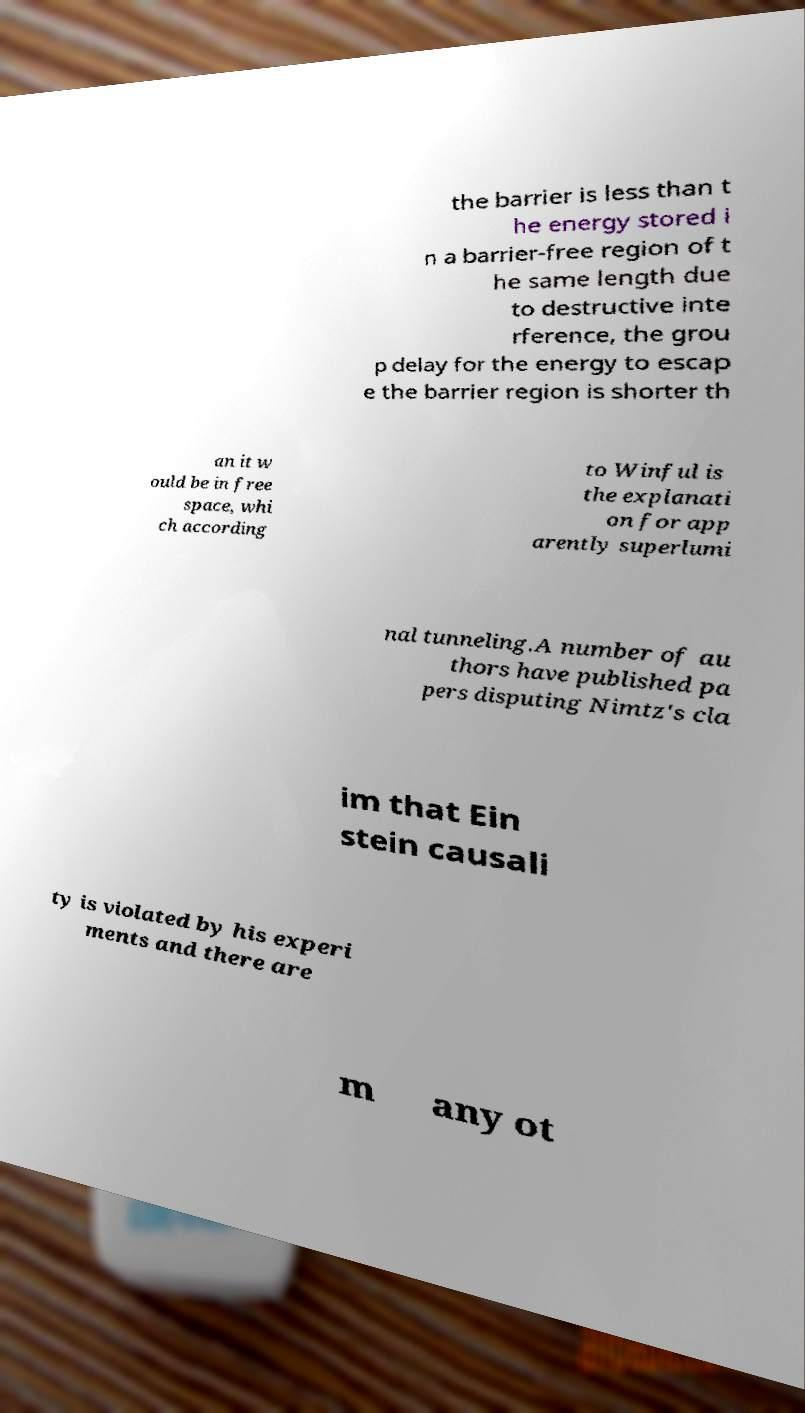Please identify and transcribe the text found in this image. the barrier is less than t he energy stored i n a barrier-free region of t he same length due to destructive inte rference, the grou p delay for the energy to escap e the barrier region is shorter th an it w ould be in free space, whi ch according to Winful is the explanati on for app arently superlumi nal tunneling.A number of au thors have published pa pers disputing Nimtz's cla im that Ein stein causali ty is violated by his experi ments and there are m any ot 